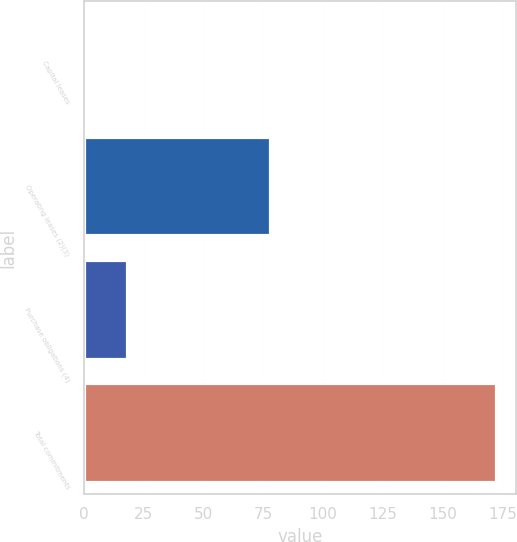Convert chart. <chart><loc_0><loc_0><loc_500><loc_500><bar_chart><fcel>Capital leases<fcel>Operating leases (2)(3)<fcel>Purchase obligations (4)<fcel>Total commitments<nl><fcel>1<fcel>78<fcel>18.1<fcel>172<nl></chart> 